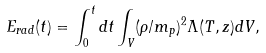Convert formula to latex. <formula><loc_0><loc_0><loc_500><loc_500>E _ { r a d } ( t ) = \int _ { 0 } ^ { t } d t \int _ { V } ( \rho / m _ { p } ) ^ { 2 } \Lambda ( T , z ) d V ,</formula> 